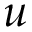Convert formula to latex. <formula><loc_0><loc_0><loc_500><loc_500>u</formula> 